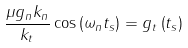<formula> <loc_0><loc_0><loc_500><loc_500>\frac { \mu g _ { n } k _ { n } } { k _ { t } } \cos \left ( \omega _ { n } t _ { s } \right ) = g _ { t } \left ( t _ { s } \right )</formula> 